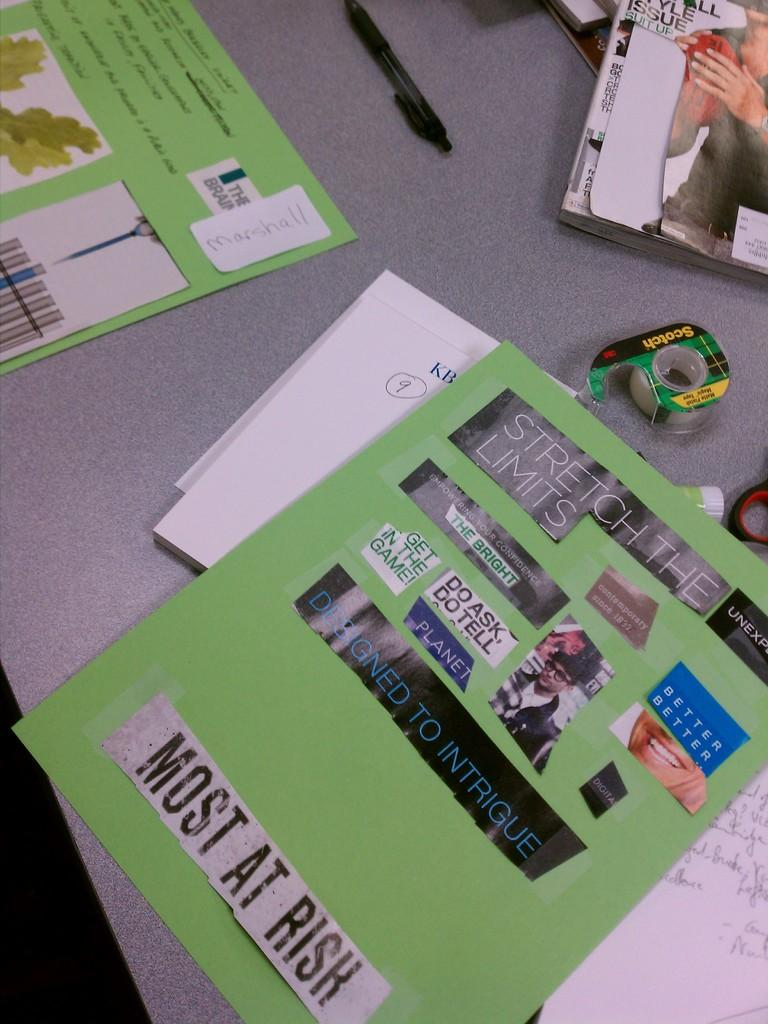<image>
Provide a brief description of the given image. The project is made out of cut up magazine photos with phrases like "most at risk", "stretch the limits", and "do ask, do tell". 